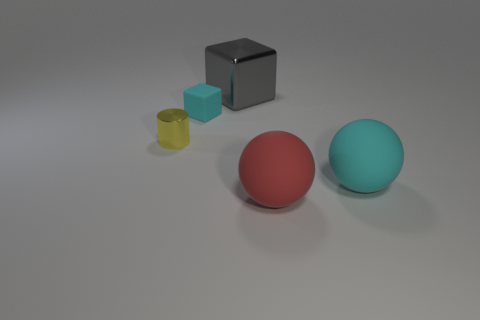Subtract all green cylinders. Subtract all yellow blocks. How many cylinders are left? 1 Subtract all green balls. How many green cylinders are left? 0 Add 5 small yellows. How many large things exist? 0 Subtract all large gray metal objects. Subtract all small cylinders. How many objects are left? 3 Add 5 big red matte spheres. How many big red matte spheres are left? 6 Add 2 tiny red rubber cylinders. How many tiny red rubber cylinders exist? 2 Add 3 big purple shiny balls. How many objects exist? 8 Subtract all cyan spheres. How many spheres are left? 1 Subtract 0 cyan cylinders. How many objects are left? 5 Subtract all cubes. How many objects are left? 3 